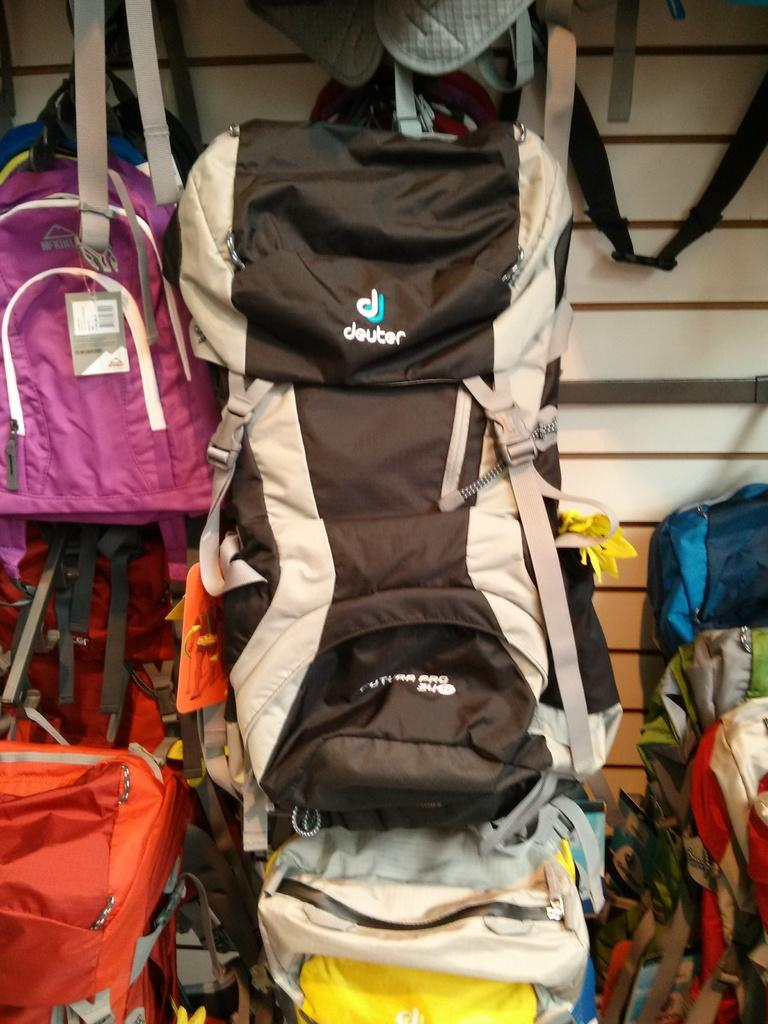What objects are present in the image? There are bags in the image. Can you describe the appearance of the bags? The bags have different colors. What type of discussion is taking place in the image? There is no discussion present in the image; it only features bags with different colors. 